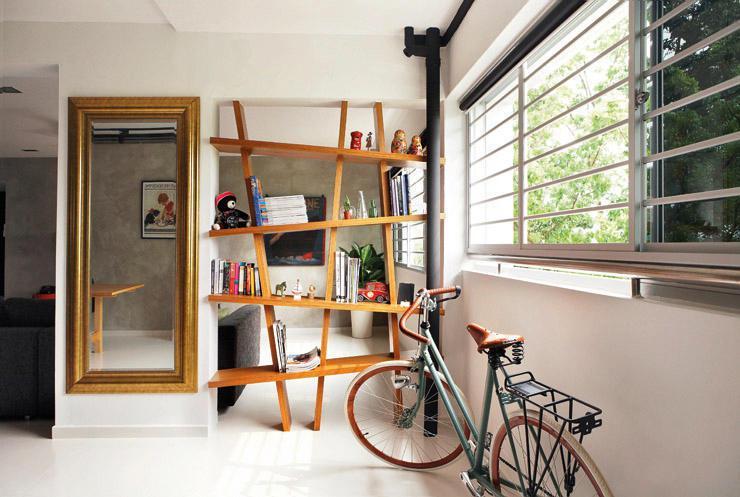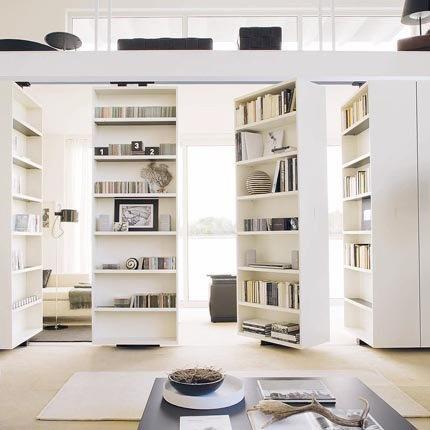The first image is the image on the left, the second image is the image on the right. Given the left and right images, does the statement "An image shows a white room with tall white bookcases and something that opens into the next room and a facing window." hold true? Answer yes or no. Yes. 